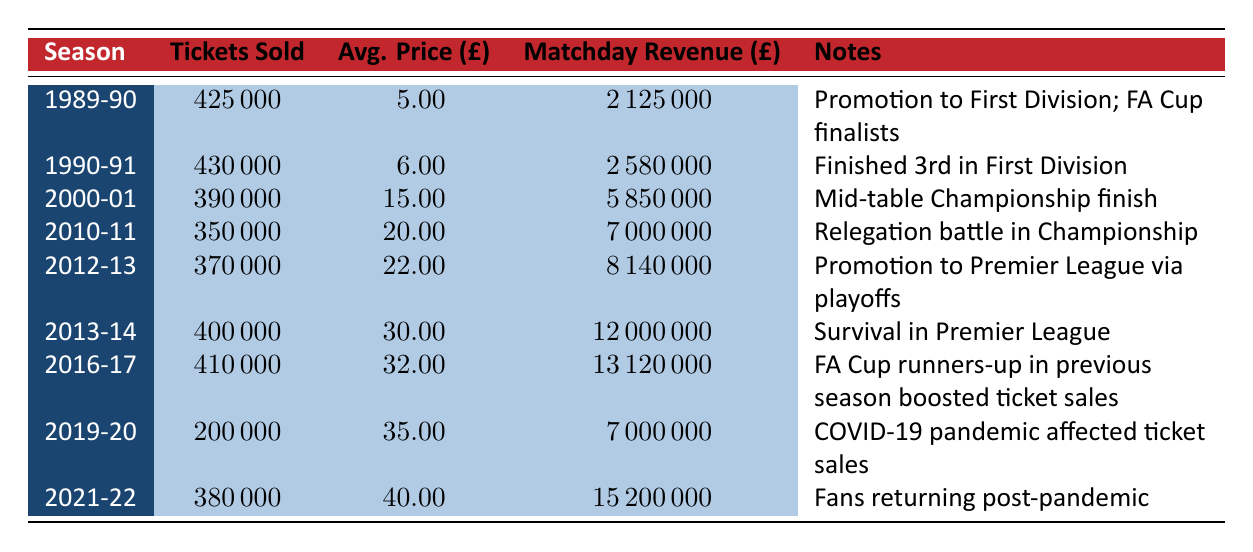What was the matchday revenue for the season 1989-90? The matchday revenue for the season 1989-90 is listed directly in the table under the corresponding season. It shows a value of £2,125,000.
Answer: £2,125,000 How many tickets were sold in the season 2016-17? Referring to the table, we can find the season 2016-17, which shows the number of tickets sold as 410,000.
Answer: 410,000 What is the average price per ticket for the season 2013-14? The table indicates the average price per ticket for the season 2013-14 directly as £30.00.
Answer: £30.00 Was there an increase in tickets sold from the season 2010-11 to 2012-13? By comparing the number of tickets sold, 350,000 in 2010-11 and 370,000 in 2012-13, there is an increase of 20,000 tickets sold, meaning yes, there was an increase.
Answer: Yes What was the total matchday revenue for the seasons 2012-13 and 2013-14 combined? To find the combined revenue, we add the matchday revenues of both seasons. For 2012-13, it’s £8,140,000, and for 2013-14, it’s £12,000,000. Summing these gives us £8,140,000 + £12,000,000 = £20,140,000.
Answer: £20,140,000 How many more tickets were sold in the season 1990-91 than in the season 1989-90? We look at the number of tickets sold in both seasons: 430,000 in 1990-91 and 425,000 in 1989-90. The difference is 430,000 - 425,000 = 5,000, indicating that 5,000 more tickets were sold in 1990-91.
Answer: 5,000 Did the average price per ticket surpass £40 in any season? Checking the average price per ticket column, it shows that the highest average price reached is £40 in the season 2021-22, but it did not surpass £40. Therefore, the answer is no.
Answer: No Which season had the lowest number of tickets sold in the last three decades? The lowest number of tickets sold is from the season 2019-20, where only 200,000 tickets were sold. We can identify this by reading through the tickets sold column in the table.
Answer: 2019-20 What is the percentage increase in matchday revenue from the season 2019-20 to 2021-22? First, we need the matchday revenues: £7,000,000 in 2019-20 and £15,200,000 in 2021-22. The increase is £15,200,000 - £7,000,000 = £8,200,000. To find the percentage increase, we divide the increase by the original value and multiply by 100: (£8,200,000 / £7,000,000) * 100 = approximately 117.14%.
Answer: Approximately 117.14% 